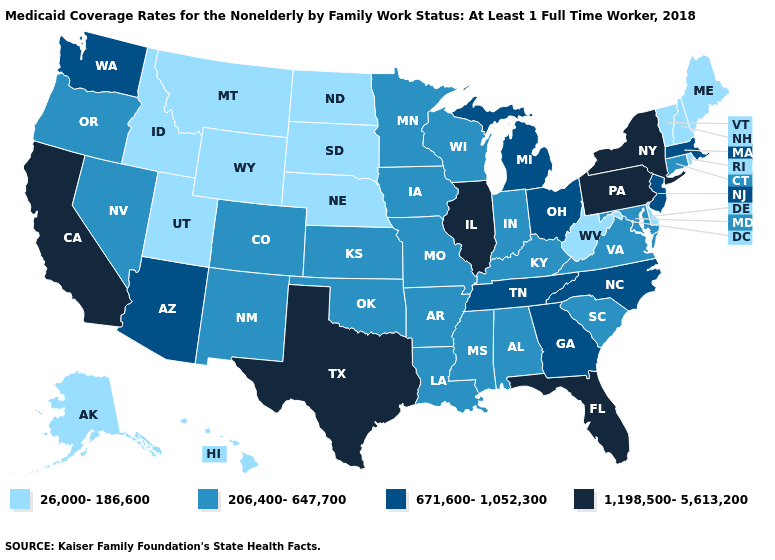What is the highest value in the USA?
Keep it brief. 1,198,500-5,613,200. Is the legend a continuous bar?
Answer briefly. No. Does Iowa have the highest value in the MidWest?
Answer briefly. No. What is the highest value in the MidWest ?
Concise answer only. 1,198,500-5,613,200. Among the states that border Wisconsin , which have the lowest value?
Short answer required. Iowa, Minnesota. Among the states that border California , does Oregon have the lowest value?
Answer briefly. Yes. What is the value of Rhode Island?
Be succinct. 26,000-186,600. Does Kansas have the same value as Iowa?
Quick response, please. Yes. Name the states that have a value in the range 1,198,500-5,613,200?
Short answer required. California, Florida, Illinois, New York, Pennsylvania, Texas. Does North Dakota have the lowest value in the USA?
Quick response, please. Yes. Which states have the lowest value in the USA?
Quick response, please. Alaska, Delaware, Hawaii, Idaho, Maine, Montana, Nebraska, New Hampshire, North Dakota, Rhode Island, South Dakota, Utah, Vermont, West Virginia, Wyoming. Does Colorado have a higher value than Idaho?
Concise answer only. Yes. Does Wyoming have a higher value than New York?
Quick response, please. No. What is the value of Texas?
Be succinct. 1,198,500-5,613,200. Name the states that have a value in the range 206,400-647,700?
Give a very brief answer. Alabama, Arkansas, Colorado, Connecticut, Indiana, Iowa, Kansas, Kentucky, Louisiana, Maryland, Minnesota, Mississippi, Missouri, Nevada, New Mexico, Oklahoma, Oregon, South Carolina, Virginia, Wisconsin. 